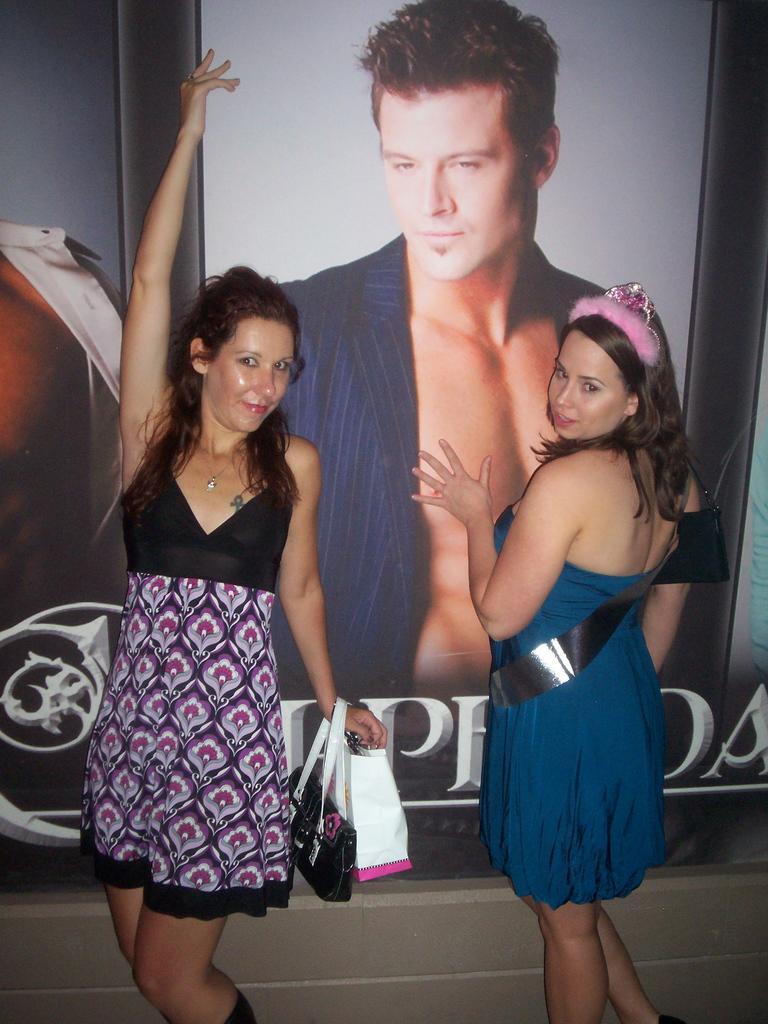In one or two sentences, can you explain what this image depicts? In the image we can see two women standing, wearing clothes and they are having handbags. Here we can see a poster of a man. 